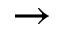Convert formula to latex. <formula><loc_0><loc_0><loc_500><loc_500>\rightarrow</formula> 